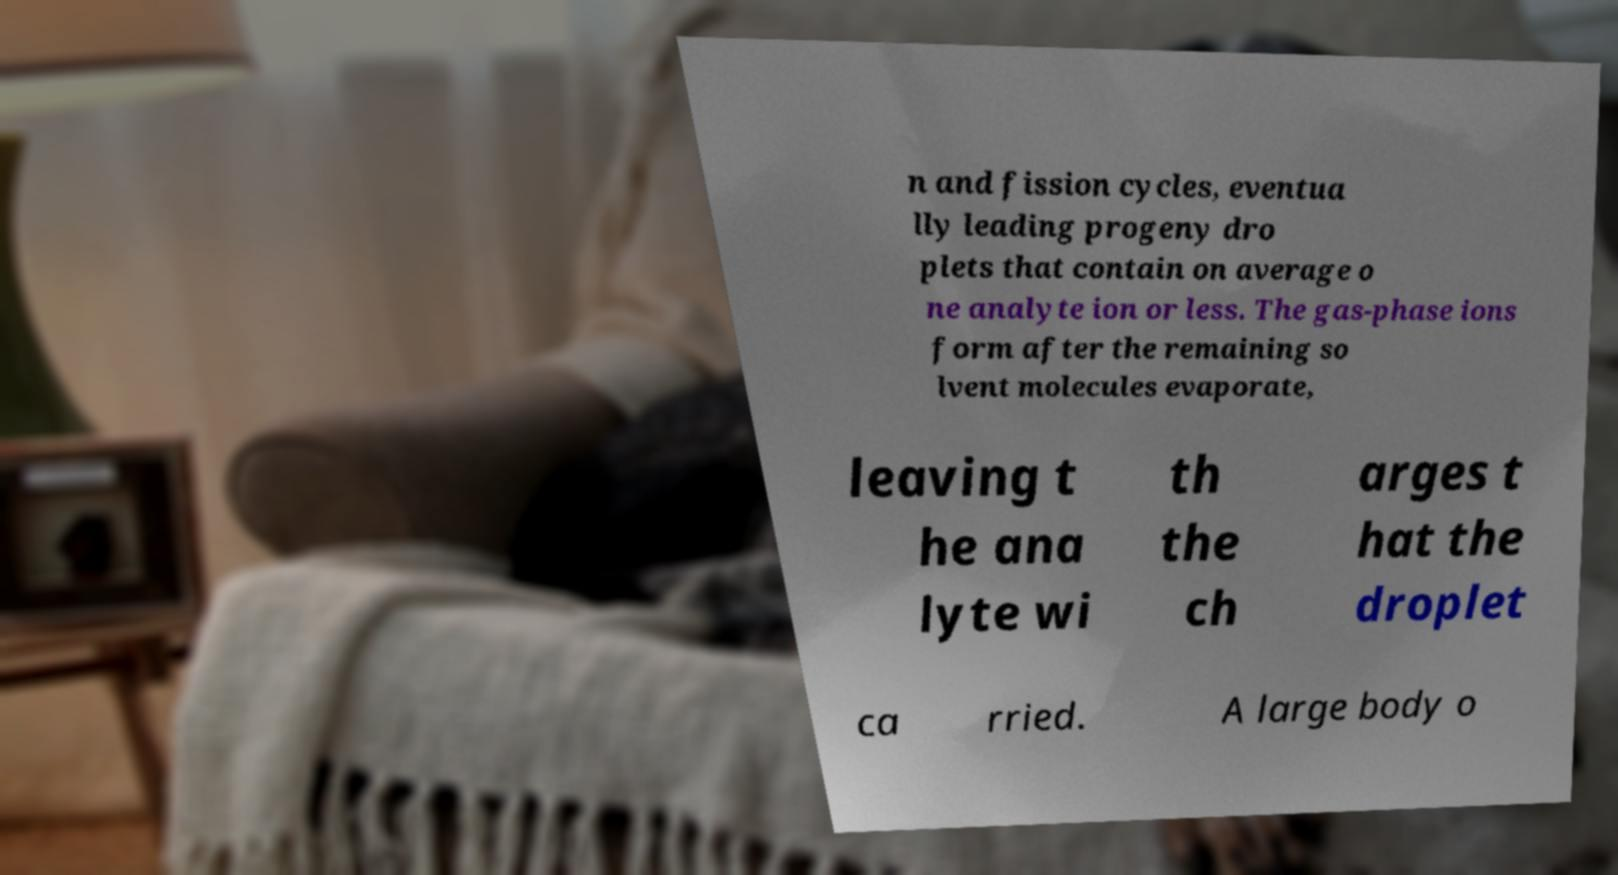For documentation purposes, I need the text within this image transcribed. Could you provide that? n and fission cycles, eventua lly leading progeny dro plets that contain on average o ne analyte ion or less. The gas-phase ions form after the remaining so lvent molecules evaporate, leaving t he ana lyte wi th the ch arges t hat the droplet ca rried. A large body o 